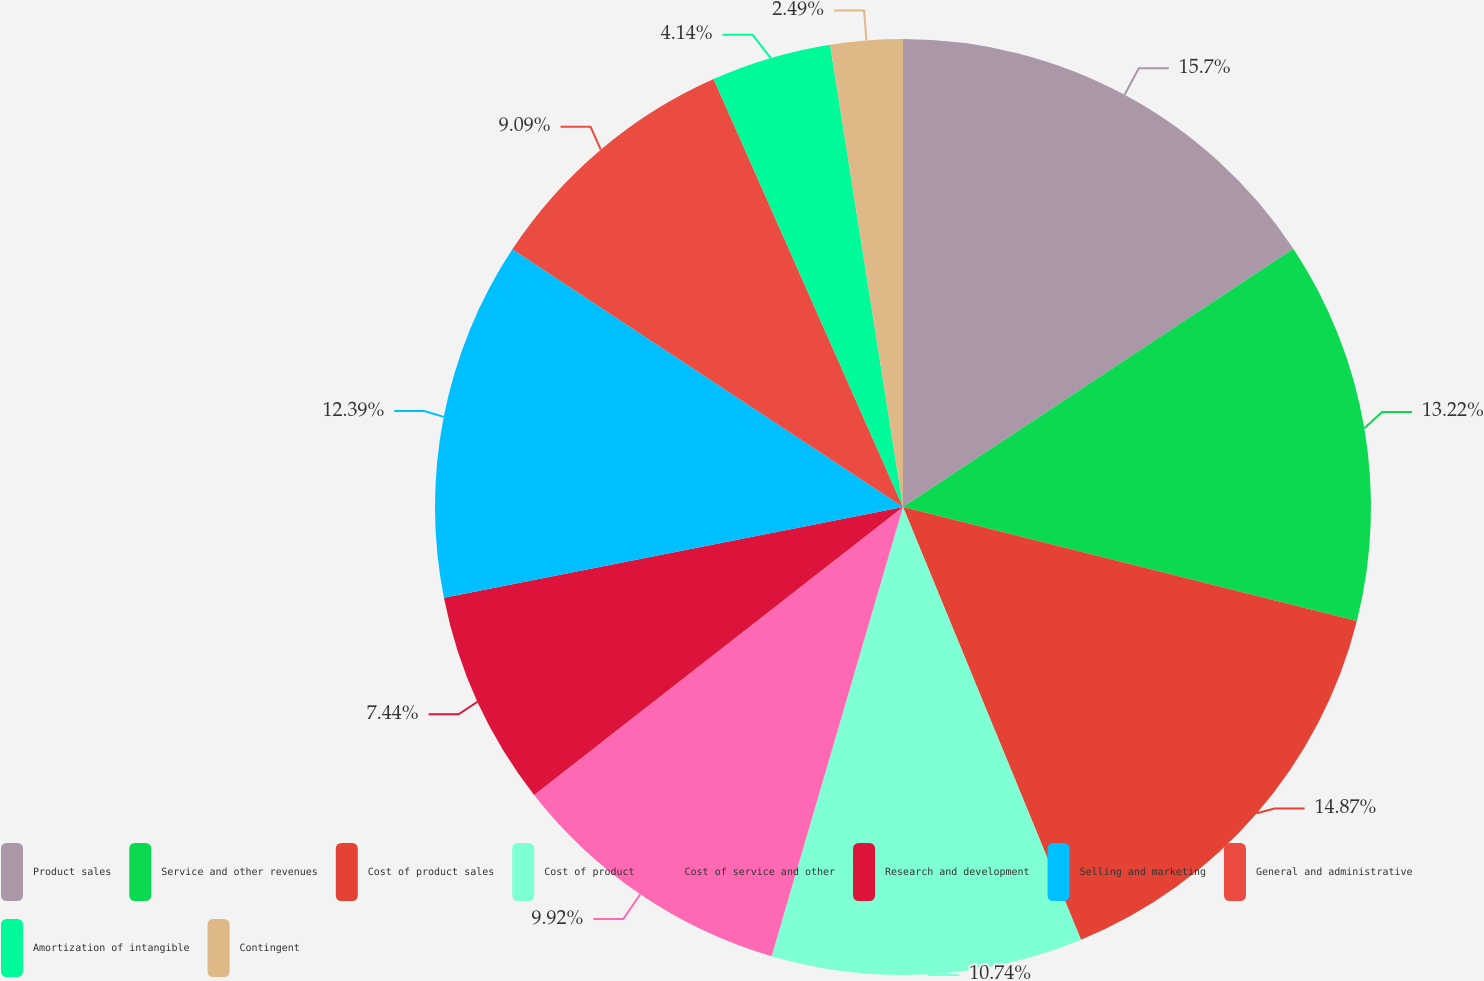<chart> <loc_0><loc_0><loc_500><loc_500><pie_chart><fcel>Product sales<fcel>Service and other revenues<fcel>Cost of product sales<fcel>Cost of product<fcel>Cost of service and other<fcel>Research and development<fcel>Selling and marketing<fcel>General and administrative<fcel>Amortization of intangible<fcel>Contingent<nl><fcel>15.7%<fcel>13.22%<fcel>14.87%<fcel>10.74%<fcel>9.92%<fcel>7.44%<fcel>12.39%<fcel>9.09%<fcel>4.14%<fcel>2.49%<nl></chart> 